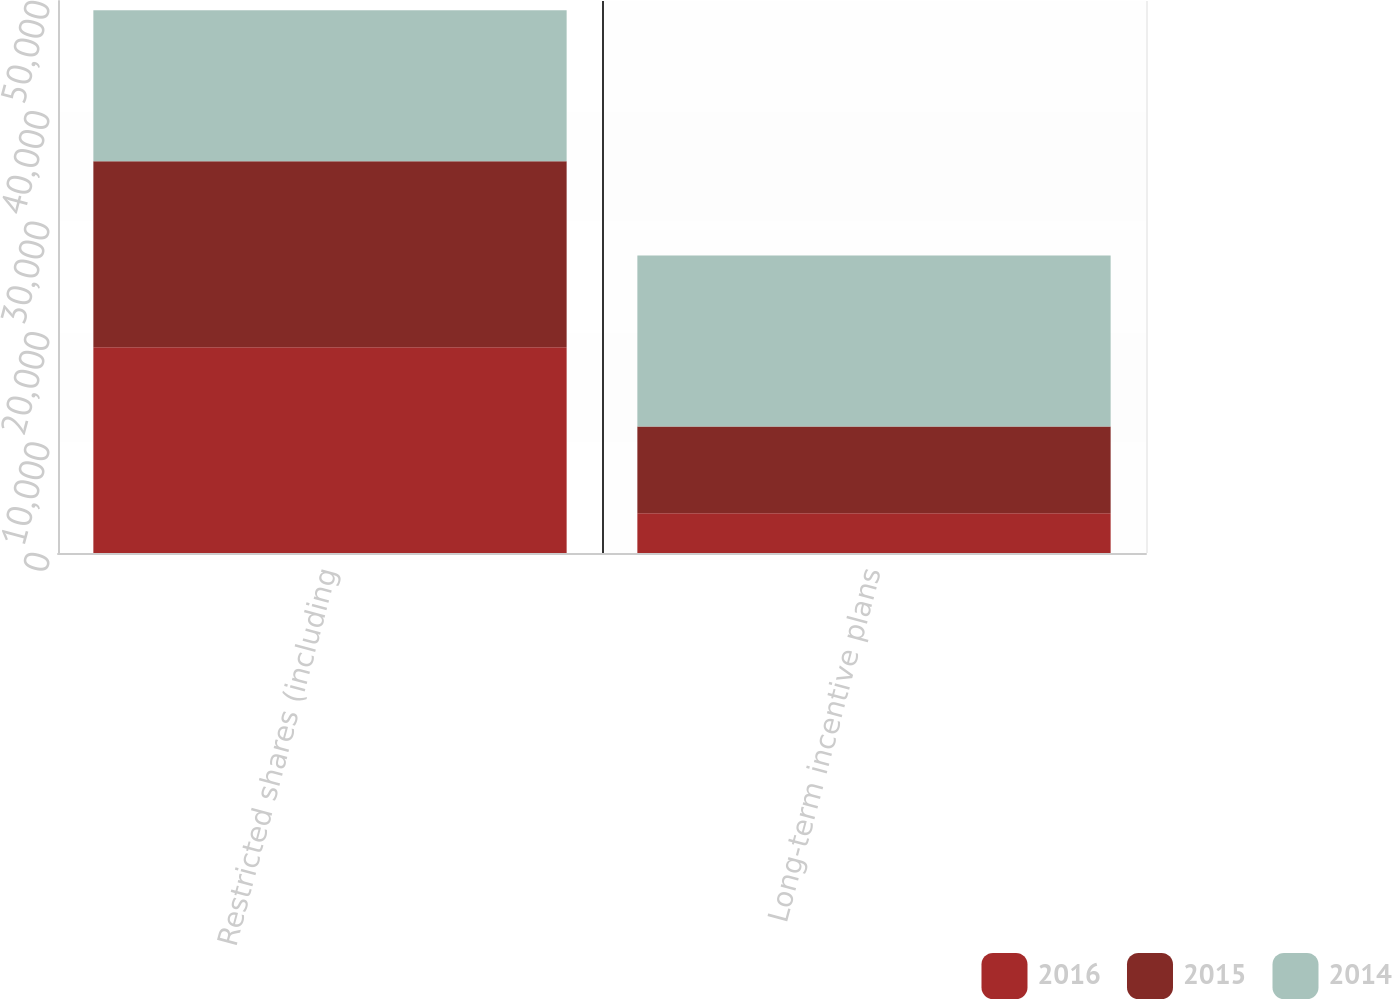<chart> <loc_0><loc_0><loc_500><loc_500><stacked_bar_chart><ecel><fcel>Restricted shares (including<fcel>Long-term incentive plans<nl><fcel>2016<fcel>18626<fcel>3602<nl><fcel>2015<fcel>16852<fcel>7863<nl><fcel>2014<fcel>13690<fcel>15481<nl></chart> 